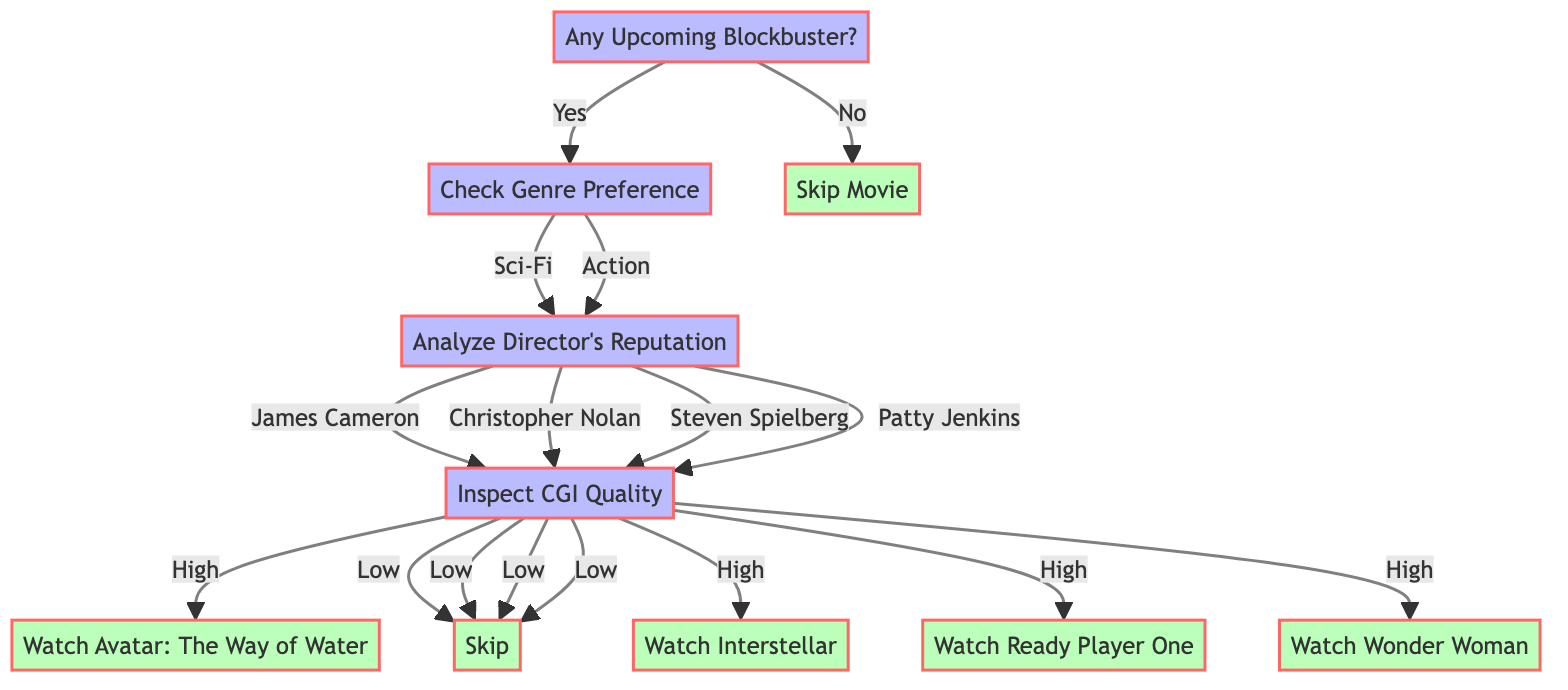What is the first decision point in the diagram? The first decision point is "Any Upcoming Blockbuster?" which asks whether there are any upcoming films to consider for viewing.
Answer: Any Upcoming Blockbuster? How many genre preferences are listed in the diagram? The diagram presents two genre preferences: "Sci-Fi" and "Action." Counting these gives a total of two genre options.
Answer: 2 If the genre preference is Sci-Fi and the director is Christopher Nolan with high CGI quality, what action should be taken? For the genre preference of Sci-Fi, selecting Christopher Nolan leads to the inspection of CGI quality. If the CGI quality is high, the action is to "Watch Interstellar."
Answer: Watch Interstellar What happens if the CGI quality is low for a movie directed by Patty Jenkins? For movies directed by Patty Jenkins, if the CGI quality is examined and found to be low, the action from that node is to "Skip." Thus, the outcome is to skip the movie.
Answer: Skip What action do you take if the answer to "Any Upcoming Blockbuster?" is No? If the answer to the initial question about upcoming blockbusters is No, the action specified in the diagram is to "Skip Movie."
Answer: Skip Movie How many directors are considered in the decision tree for the action genre? The diagram includes two directors for the action genre: Steven Spielberg and Patty Jenkins, making a total of two directors considered.
Answer: 2 What is the outcome if the genre is Action and the CGI quality is found to be high? In this case, the outcome for the action genre with high CGI quality directed by Steven Spielberg is "Watch Ready Player One."
Answer: Watch Ready Player One Which director has a movie that should be watched if the genre is Sci-Fi and CGI quality is high? The director associated with a sci-fi movie that should be watched, given high CGI quality, is James Cameron, leading to the action "Watch Avatar: The Way of Water."
Answer: Watch Avatar: The Way of Water If you prefer Action movies, which decision follows after "Check Genre Preference"? After selecting the Action genre under "Check Genre Preference," the next decision point will be to "Analyze Director's Reputation."
Answer: Analyze Director's Reputation What do you check after determining the genre preference? After determining the genre preference, you check the "Analyze Director's Reputation" to evaluate the chosen director's reputation.
Answer: Analyze Director's Reputation 